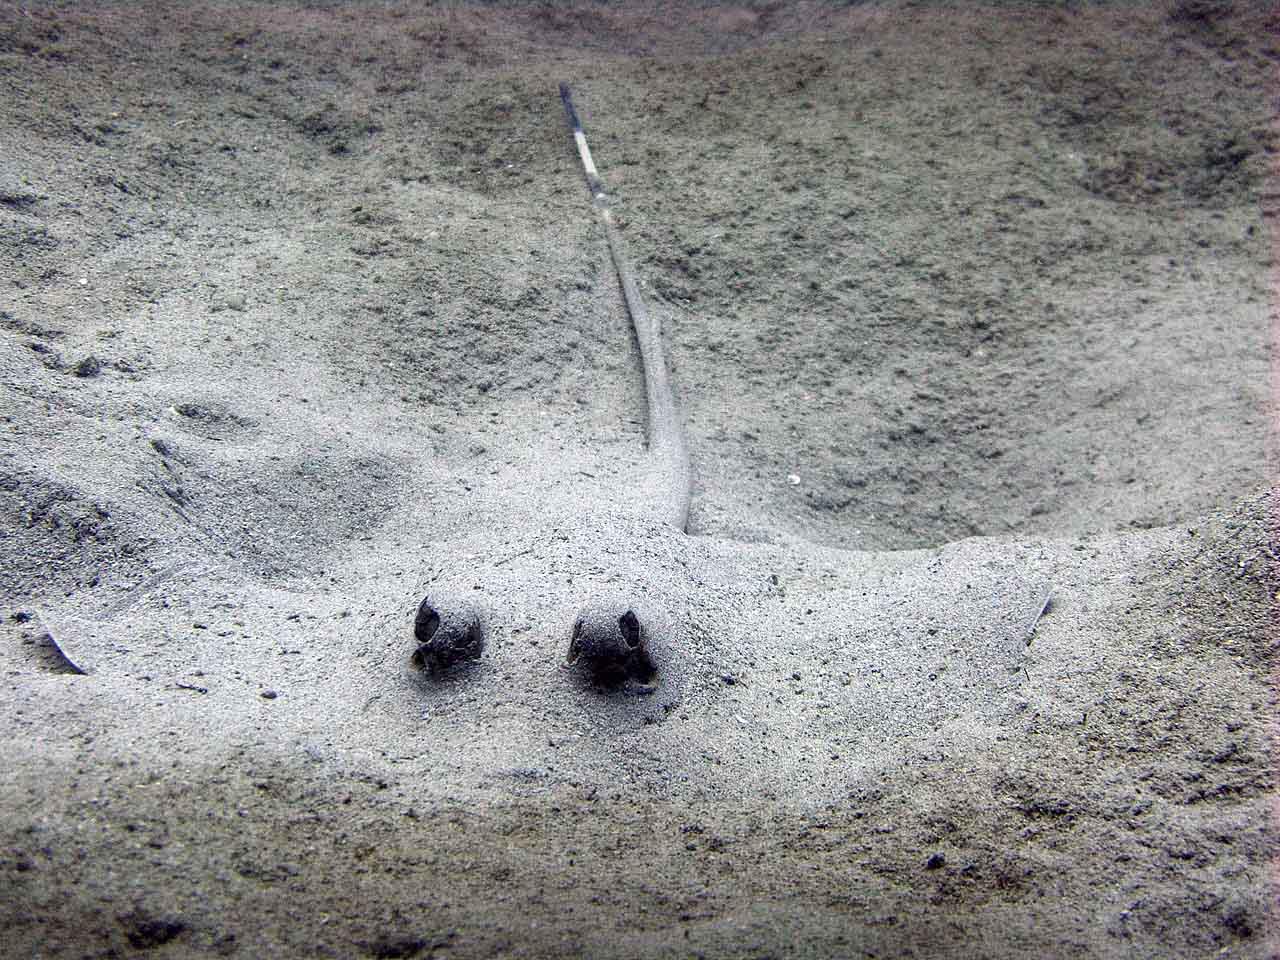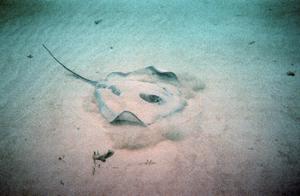The first image is the image on the left, the second image is the image on the right. Given the left and right images, does the statement "One image shows a camera-facing stingray mostly covered in sand, with black eyes projecting out." hold true? Answer yes or no. Yes. 